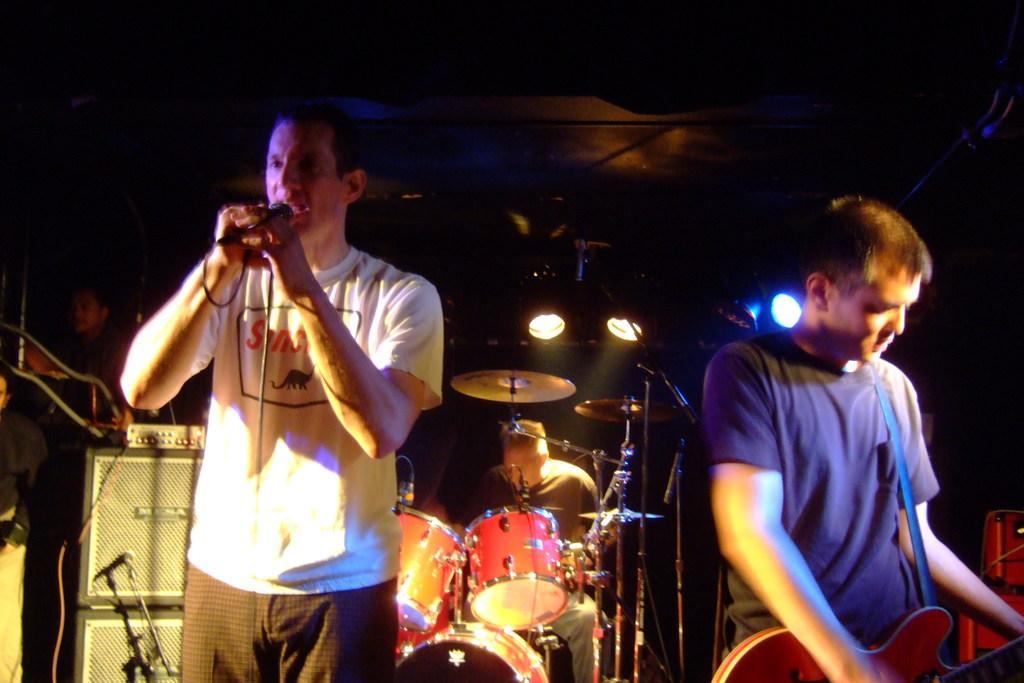Please provide a concise description of this image. There is a group of people on a stage. They are playing musical instruments. 